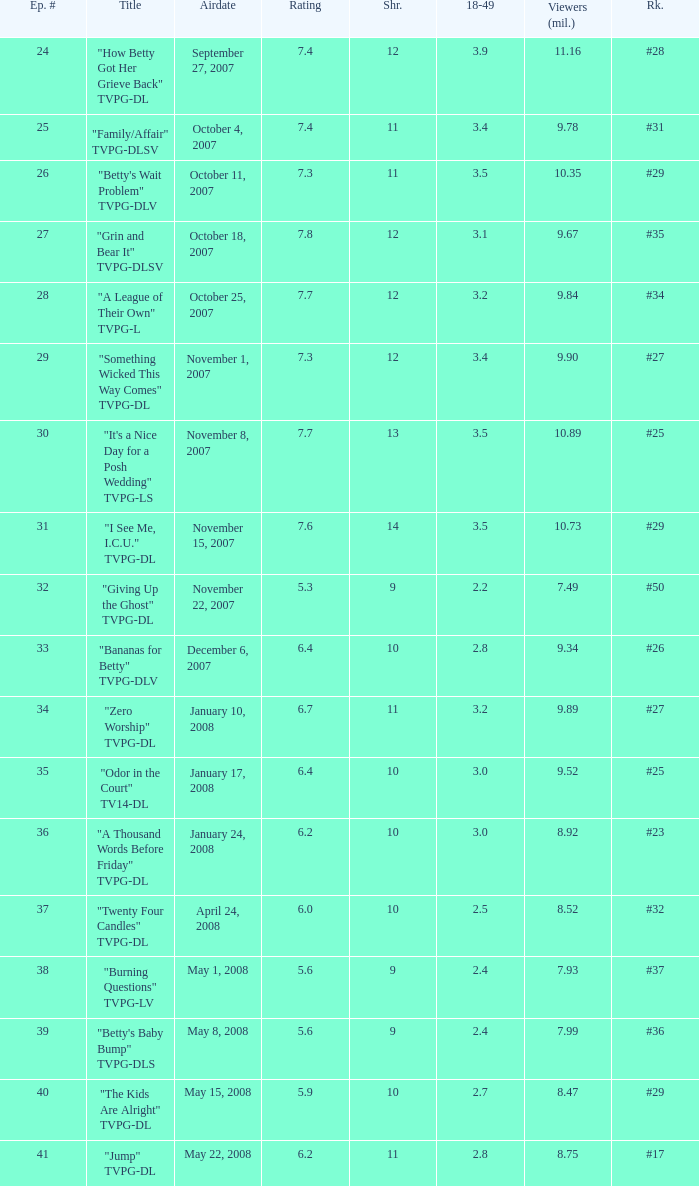Could you parse the entire table? {'header': ['Ep. #', 'Title', 'Airdate', 'Rating', 'Shr.', '18-49', 'Viewers (mil.)', 'Rk.'], 'rows': [['24', '"How Betty Got Her Grieve Back" TVPG-DL', 'September 27, 2007', '7.4', '12', '3.9', '11.16', '#28'], ['25', '"Family/Affair" TVPG-DLSV', 'October 4, 2007', '7.4', '11', '3.4', '9.78', '#31'], ['26', '"Betty\'s Wait Problem" TVPG-DLV', 'October 11, 2007', '7.3', '11', '3.5', '10.35', '#29'], ['27', '"Grin and Bear It" TVPG-DLSV', 'October 18, 2007', '7.8', '12', '3.1', '9.67', '#35'], ['28', '"A League of Their Own" TVPG-L', 'October 25, 2007', '7.7', '12', '3.2', '9.84', '#34'], ['29', '"Something Wicked This Way Comes" TVPG-DL', 'November 1, 2007', '7.3', '12', '3.4', '9.90', '#27'], ['30', '"It\'s a Nice Day for a Posh Wedding" TVPG-LS', 'November 8, 2007', '7.7', '13', '3.5', '10.89', '#25'], ['31', '"I See Me, I.C.U." TVPG-DL', 'November 15, 2007', '7.6', '14', '3.5', '10.73', '#29'], ['32', '"Giving Up the Ghost" TVPG-DL', 'November 22, 2007', '5.3', '9', '2.2', '7.49', '#50'], ['33', '"Bananas for Betty" TVPG-DLV', 'December 6, 2007', '6.4', '10', '2.8', '9.34', '#26'], ['34', '"Zero Worship" TVPG-DL', 'January 10, 2008', '6.7', '11', '3.2', '9.89', '#27'], ['35', '"Odor in the Court" TV14-DL', 'January 17, 2008', '6.4', '10', '3.0', '9.52', '#25'], ['36', '"A Thousand Words Before Friday" TVPG-DL', 'January 24, 2008', '6.2', '10', '3.0', '8.92', '#23'], ['37', '"Twenty Four Candles" TVPG-DL', 'April 24, 2008', '6.0', '10', '2.5', '8.52', '#32'], ['38', '"Burning Questions" TVPG-LV', 'May 1, 2008', '5.6', '9', '2.4', '7.93', '#37'], ['39', '"Betty\'s Baby Bump" TVPG-DLS', 'May 8, 2008', '5.6', '9', '2.4', '7.99', '#36'], ['40', '"The Kids Are Alright" TVPG-DL', 'May 15, 2008', '5.9', '10', '2.7', '8.47', '#29'], ['41', '"Jump" TVPG-DL', 'May 22, 2008', '6.2', '11', '2.8', '8.75', '#17']]} What is the Airdate of the episode that ranked #29 and had a share greater than 10? May 15, 2008. 